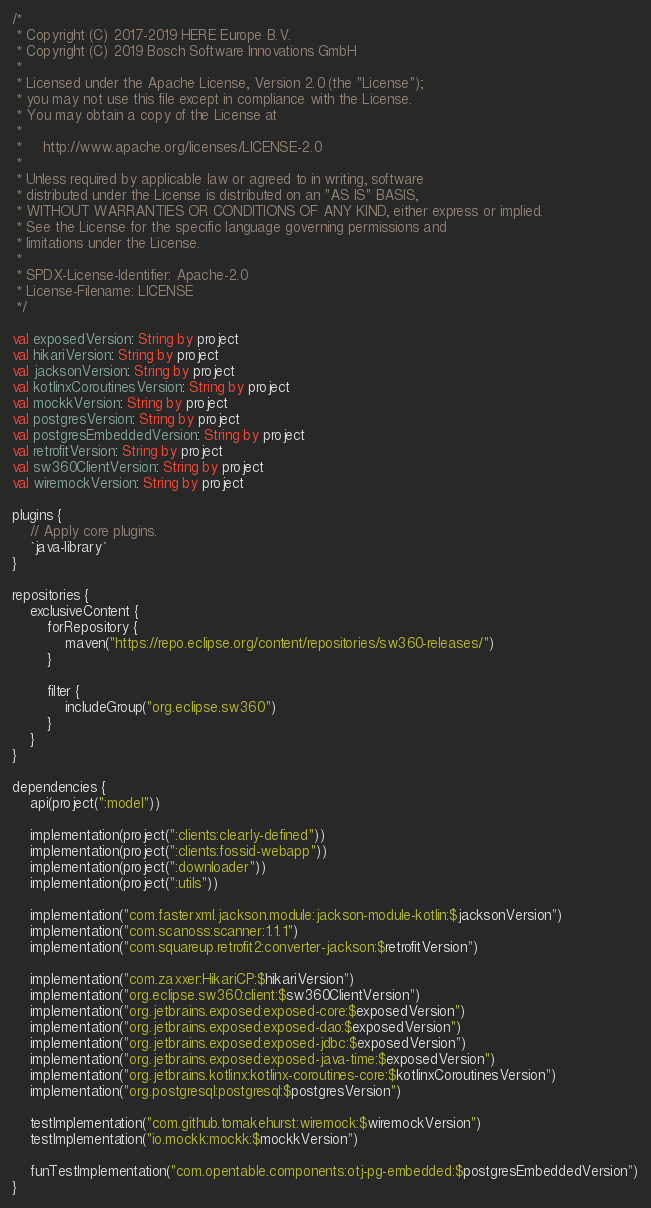Convert code to text. <code><loc_0><loc_0><loc_500><loc_500><_Kotlin_>/*
 * Copyright (C) 2017-2019 HERE Europe B.V.
 * Copyright (C) 2019 Bosch Software Innovations GmbH
 *
 * Licensed under the Apache License, Version 2.0 (the "License");
 * you may not use this file except in compliance with the License.
 * You may obtain a copy of the License at
 *
 *     http://www.apache.org/licenses/LICENSE-2.0
 *
 * Unless required by applicable law or agreed to in writing, software
 * distributed under the License is distributed on an "AS IS" BASIS,
 * WITHOUT WARRANTIES OR CONDITIONS OF ANY KIND, either express or implied.
 * See the License for the specific language governing permissions and
 * limitations under the License.
 *
 * SPDX-License-Identifier: Apache-2.0
 * License-Filename: LICENSE
 */

val exposedVersion: String by project
val hikariVersion: String by project
val jacksonVersion: String by project
val kotlinxCoroutinesVersion: String by project
val mockkVersion: String by project
val postgresVersion: String by project
val postgresEmbeddedVersion: String by project
val retrofitVersion: String by project
val sw360ClientVersion: String by project
val wiremockVersion: String by project

plugins {
    // Apply core plugins.
    `java-library`
}

repositories {
    exclusiveContent {
        forRepository {
            maven("https://repo.eclipse.org/content/repositories/sw360-releases/")
        }

        filter {
            includeGroup("org.eclipse.sw360")
        }
    }
}

dependencies {
    api(project(":model"))

    implementation(project(":clients:clearly-defined"))
    implementation(project(":clients:fossid-webapp"))
    implementation(project(":downloader"))
    implementation(project(":utils"))

    implementation("com.fasterxml.jackson.module:jackson-module-kotlin:$jacksonVersion")
    implementation("com.scanoss:scanner:1.1.1")
    implementation("com.squareup.retrofit2:converter-jackson:$retrofitVersion")

    implementation("com.zaxxer:HikariCP:$hikariVersion")
    implementation("org.eclipse.sw360:client:$sw360ClientVersion")
    implementation("org.jetbrains.exposed:exposed-core:$exposedVersion")
    implementation("org.jetbrains.exposed:exposed-dao:$exposedVersion")
    implementation("org.jetbrains.exposed:exposed-jdbc:$exposedVersion")
    implementation("org.jetbrains.exposed:exposed-java-time:$exposedVersion")
    implementation("org.jetbrains.kotlinx:kotlinx-coroutines-core:$kotlinxCoroutinesVersion")
    implementation("org.postgresql:postgresql:$postgresVersion")

    testImplementation("com.github.tomakehurst:wiremock:$wiremockVersion")
    testImplementation("io.mockk:mockk:$mockkVersion")

    funTestImplementation("com.opentable.components:otj-pg-embedded:$postgresEmbeddedVersion")
}
</code> 